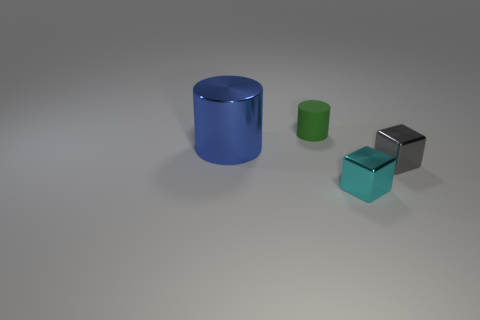Is there any other thing that has the same size as the shiny cylinder?
Provide a short and direct response. No. Is there anything else that has the same material as the tiny green thing?
Your answer should be very brief. No. How many other things are the same shape as the green object?
Offer a very short reply. 1. Is the number of tiny green rubber things left of the metallic cylinder greater than the number of cyan shiny things that are behind the gray metal object?
Your answer should be very brief. No. How many other things are the same size as the cyan object?
Offer a very short reply. 2. Do the cylinder that is on the left side of the tiny cylinder and the matte cylinder have the same color?
Make the answer very short. No. Is the number of tiny gray objects that are right of the small gray cube greater than the number of small gray metallic cubes?
Provide a succinct answer. No. Is there any other thing that has the same color as the big thing?
Your response must be concise. No. The small object behind the metallic object left of the small matte cylinder is what shape?
Provide a succinct answer. Cylinder. Are there more tiny green cylinders than small gray shiny cylinders?
Offer a terse response. Yes. 